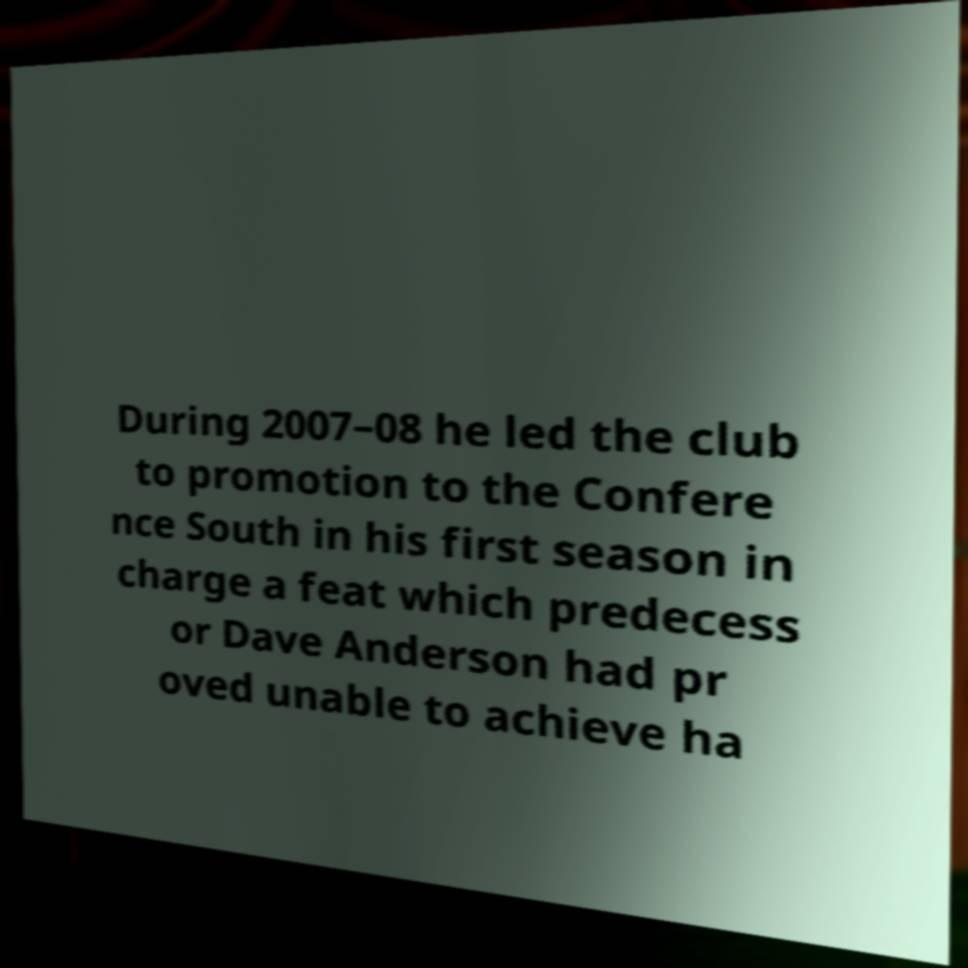Can you accurately transcribe the text from the provided image for me? During 2007–08 he led the club to promotion to the Confere nce South in his first season in charge a feat which predecess or Dave Anderson had pr oved unable to achieve ha 